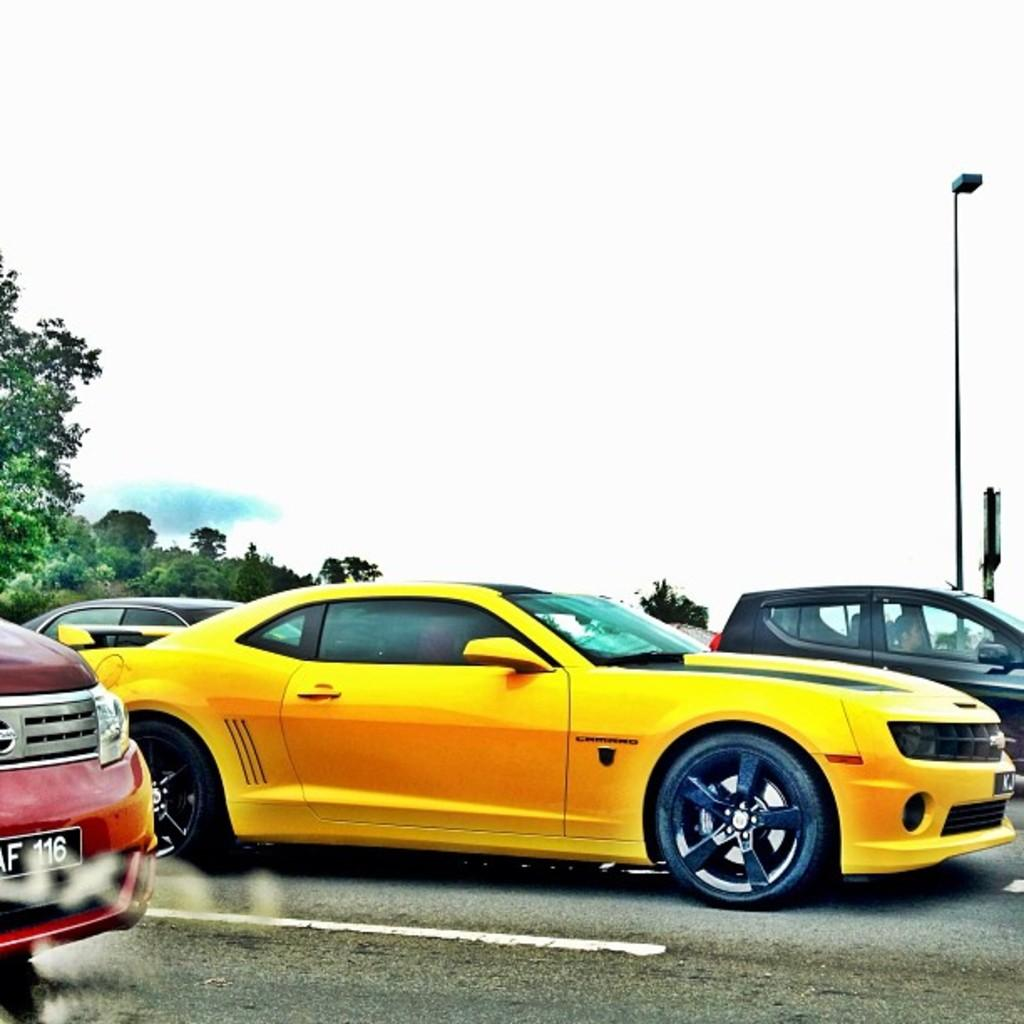What is the main feature of the image? There is a road in the image. What is happening on the road? There are cars on the road. What can be seen in the background of the image? There is a pole, trees, and the sky visible in the background of the image. How many snails are crawling on the road in the image? There are no snails visible on the road in the image. What shape is the pole in the background of the image? The provided facts do not mention the shape of the pole; only its presence is noted. 